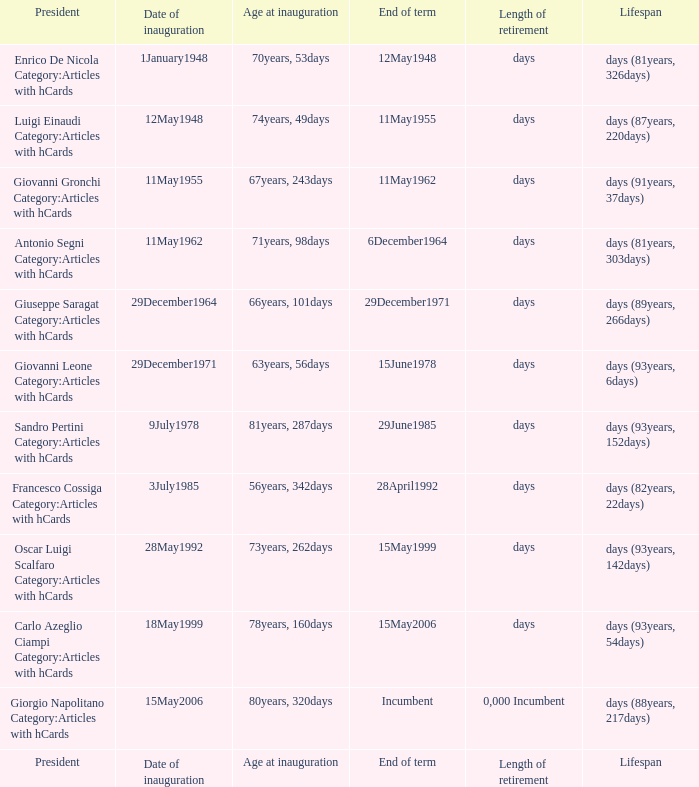What is the duration of retirement for a president who was inaugurated at the age of 70 years and 53 days? Days. 